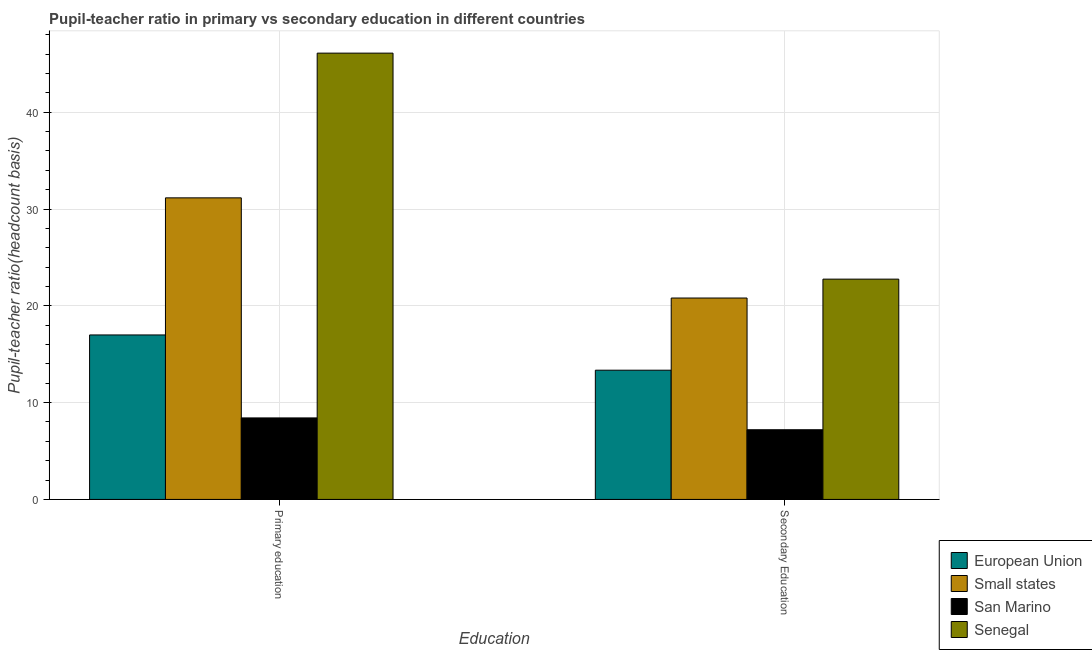How many different coloured bars are there?
Offer a very short reply. 4. Are the number of bars on each tick of the X-axis equal?
Ensure brevity in your answer.  Yes. How many bars are there on the 2nd tick from the right?
Give a very brief answer. 4. What is the label of the 2nd group of bars from the left?
Provide a succinct answer. Secondary Education. What is the pupil-teacher ratio in primary education in European Union?
Your answer should be compact. 16.99. Across all countries, what is the maximum pupil teacher ratio on secondary education?
Provide a succinct answer. 22.76. Across all countries, what is the minimum pupil-teacher ratio in primary education?
Give a very brief answer. 8.42. In which country was the pupil teacher ratio on secondary education maximum?
Your response must be concise. Senegal. In which country was the pupil-teacher ratio in primary education minimum?
Your response must be concise. San Marino. What is the total pupil-teacher ratio in primary education in the graph?
Your answer should be compact. 102.68. What is the difference between the pupil teacher ratio on secondary education in European Union and that in San Marino?
Keep it short and to the point. 6.15. What is the difference between the pupil teacher ratio on secondary education in Small states and the pupil-teacher ratio in primary education in European Union?
Give a very brief answer. 3.81. What is the average pupil-teacher ratio in primary education per country?
Make the answer very short. 25.67. What is the difference between the pupil teacher ratio on secondary education and pupil-teacher ratio in primary education in San Marino?
Offer a very short reply. -1.22. In how many countries, is the pupil-teacher ratio in primary education greater than 4 ?
Your answer should be compact. 4. What is the ratio of the pupil teacher ratio on secondary education in Small states to that in Senegal?
Offer a very short reply. 0.91. Is the pupil teacher ratio on secondary education in Senegal less than that in Small states?
Provide a short and direct response. No. What does the 3rd bar from the left in Primary education represents?
Offer a terse response. San Marino. What does the 1st bar from the right in Primary education represents?
Make the answer very short. Senegal. Are all the bars in the graph horizontal?
Your response must be concise. No. Where does the legend appear in the graph?
Keep it short and to the point. Bottom right. How many legend labels are there?
Offer a terse response. 4. How are the legend labels stacked?
Ensure brevity in your answer.  Vertical. What is the title of the graph?
Ensure brevity in your answer.  Pupil-teacher ratio in primary vs secondary education in different countries. Does "Zambia" appear as one of the legend labels in the graph?
Offer a very short reply. No. What is the label or title of the X-axis?
Ensure brevity in your answer.  Education. What is the label or title of the Y-axis?
Offer a terse response. Pupil-teacher ratio(headcount basis). What is the Pupil-teacher ratio(headcount basis) in European Union in Primary education?
Keep it short and to the point. 16.99. What is the Pupil-teacher ratio(headcount basis) of Small states in Primary education?
Provide a succinct answer. 31.16. What is the Pupil-teacher ratio(headcount basis) of San Marino in Primary education?
Offer a terse response. 8.42. What is the Pupil-teacher ratio(headcount basis) in Senegal in Primary education?
Keep it short and to the point. 46.11. What is the Pupil-teacher ratio(headcount basis) of European Union in Secondary Education?
Offer a very short reply. 13.35. What is the Pupil-teacher ratio(headcount basis) of Small states in Secondary Education?
Your response must be concise. 20.81. What is the Pupil-teacher ratio(headcount basis) of San Marino in Secondary Education?
Provide a short and direct response. 7.2. What is the Pupil-teacher ratio(headcount basis) in Senegal in Secondary Education?
Ensure brevity in your answer.  22.76. Across all Education, what is the maximum Pupil-teacher ratio(headcount basis) of European Union?
Your response must be concise. 16.99. Across all Education, what is the maximum Pupil-teacher ratio(headcount basis) of Small states?
Your answer should be very brief. 31.16. Across all Education, what is the maximum Pupil-teacher ratio(headcount basis) in San Marino?
Provide a short and direct response. 8.42. Across all Education, what is the maximum Pupil-teacher ratio(headcount basis) in Senegal?
Your answer should be compact. 46.11. Across all Education, what is the minimum Pupil-teacher ratio(headcount basis) in European Union?
Your answer should be compact. 13.35. Across all Education, what is the minimum Pupil-teacher ratio(headcount basis) in Small states?
Provide a succinct answer. 20.81. Across all Education, what is the minimum Pupil-teacher ratio(headcount basis) of Senegal?
Your answer should be compact. 22.76. What is the total Pupil-teacher ratio(headcount basis) of European Union in the graph?
Offer a terse response. 30.35. What is the total Pupil-teacher ratio(headcount basis) of Small states in the graph?
Your response must be concise. 51.97. What is the total Pupil-teacher ratio(headcount basis) in San Marino in the graph?
Keep it short and to the point. 15.62. What is the total Pupil-teacher ratio(headcount basis) in Senegal in the graph?
Your answer should be compact. 68.87. What is the difference between the Pupil-teacher ratio(headcount basis) in European Union in Primary education and that in Secondary Education?
Your answer should be very brief. 3.64. What is the difference between the Pupil-teacher ratio(headcount basis) of Small states in Primary education and that in Secondary Education?
Provide a succinct answer. 10.35. What is the difference between the Pupil-teacher ratio(headcount basis) in San Marino in Primary education and that in Secondary Education?
Ensure brevity in your answer.  1.22. What is the difference between the Pupil-teacher ratio(headcount basis) in Senegal in Primary education and that in Secondary Education?
Ensure brevity in your answer.  23.35. What is the difference between the Pupil-teacher ratio(headcount basis) in European Union in Primary education and the Pupil-teacher ratio(headcount basis) in Small states in Secondary Education?
Offer a very short reply. -3.81. What is the difference between the Pupil-teacher ratio(headcount basis) in European Union in Primary education and the Pupil-teacher ratio(headcount basis) in San Marino in Secondary Education?
Make the answer very short. 9.79. What is the difference between the Pupil-teacher ratio(headcount basis) in European Union in Primary education and the Pupil-teacher ratio(headcount basis) in Senegal in Secondary Education?
Ensure brevity in your answer.  -5.77. What is the difference between the Pupil-teacher ratio(headcount basis) in Small states in Primary education and the Pupil-teacher ratio(headcount basis) in San Marino in Secondary Education?
Your response must be concise. 23.96. What is the difference between the Pupil-teacher ratio(headcount basis) of Small states in Primary education and the Pupil-teacher ratio(headcount basis) of Senegal in Secondary Education?
Provide a succinct answer. 8.4. What is the difference between the Pupil-teacher ratio(headcount basis) in San Marino in Primary education and the Pupil-teacher ratio(headcount basis) in Senegal in Secondary Education?
Give a very brief answer. -14.34. What is the average Pupil-teacher ratio(headcount basis) in European Union per Education?
Make the answer very short. 15.17. What is the average Pupil-teacher ratio(headcount basis) in Small states per Education?
Keep it short and to the point. 25.98. What is the average Pupil-teacher ratio(headcount basis) of San Marino per Education?
Your answer should be compact. 7.81. What is the average Pupil-teacher ratio(headcount basis) in Senegal per Education?
Your response must be concise. 34.44. What is the difference between the Pupil-teacher ratio(headcount basis) in European Union and Pupil-teacher ratio(headcount basis) in Small states in Primary education?
Offer a very short reply. -14.16. What is the difference between the Pupil-teacher ratio(headcount basis) in European Union and Pupil-teacher ratio(headcount basis) in San Marino in Primary education?
Give a very brief answer. 8.57. What is the difference between the Pupil-teacher ratio(headcount basis) in European Union and Pupil-teacher ratio(headcount basis) in Senegal in Primary education?
Your answer should be compact. -29.12. What is the difference between the Pupil-teacher ratio(headcount basis) in Small states and Pupil-teacher ratio(headcount basis) in San Marino in Primary education?
Your response must be concise. 22.74. What is the difference between the Pupil-teacher ratio(headcount basis) of Small states and Pupil-teacher ratio(headcount basis) of Senegal in Primary education?
Your answer should be very brief. -14.95. What is the difference between the Pupil-teacher ratio(headcount basis) in San Marino and Pupil-teacher ratio(headcount basis) in Senegal in Primary education?
Keep it short and to the point. -37.69. What is the difference between the Pupil-teacher ratio(headcount basis) in European Union and Pupil-teacher ratio(headcount basis) in Small states in Secondary Education?
Provide a succinct answer. -7.46. What is the difference between the Pupil-teacher ratio(headcount basis) in European Union and Pupil-teacher ratio(headcount basis) in San Marino in Secondary Education?
Your response must be concise. 6.15. What is the difference between the Pupil-teacher ratio(headcount basis) in European Union and Pupil-teacher ratio(headcount basis) in Senegal in Secondary Education?
Ensure brevity in your answer.  -9.41. What is the difference between the Pupil-teacher ratio(headcount basis) in Small states and Pupil-teacher ratio(headcount basis) in San Marino in Secondary Education?
Your answer should be very brief. 13.61. What is the difference between the Pupil-teacher ratio(headcount basis) of Small states and Pupil-teacher ratio(headcount basis) of Senegal in Secondary Education?
Give a very brief answer. -1.95. What is the difference between the Pupil-teacher ratio(headcount basis) of San Marino and Pupil-teacher ratio(headcount basis) of Senegal in Secondary Education?
Give a very brief answer. -15.56. What is the ratio of the Pupil-teacher ratio(headcount basis) in European Union in Primary education to that in Secondary Education?
Your answer should be very brief. 1.27. What is the ratio of the Pupil-teacher ratio(headcount basis) of Small states in Primary education to that in Secondary Education?
Make the answer very short. 1.5. What is the ratio of the Pupil-teacher ratio(headcount basis) of San Marino in Primary education to that in Secondary Education?
Keep it short and to the point. 1.17. What is the ratio of the Pupil-teacher ratio(headcount basis) in Senegal in Primary education to that in Secondary Education?
Keep it short and to the point. 2.03. What is the difference between the highest and the second highest Pupil-teacher ratio(headcount basis) in European Union?
Your answer should be compact. 3.64. What is the difference between the highest and the second highest Pupil-teacher ratio(headcount basis) in Small states?
Provide a short and direct response. 10.35. What is the difference between the highest and the second highest Pupil-teacher ratio(headcount basis) in San Marino?
Make the answer very short. 1.22. What is the difference between the highest and the second highest Pupil-teacher ratio(headcount basis) of Senegal?
Your response must be concise. 23.35. What is the difference between the highest and the lowest Pupil-teacher ratio(headcount basis) in European Union?
Provide a succinct answer. 3.64. What is the difference between the highest and the lowest Pupil-teacher ratio(headcount basis) in Small states?
Keep it short and to the point. 10.35. What is the difference between the highest and the lowest Pupil-teacher ratio(headcount basis) in San Marino?
Offer a terse response. 1.22. What is the difference between the highest and the lowest Pupil-teacher ratio(headcount basis) of Senegal?
Your response must be concise. 23.35. 